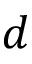<formula> <loc_0><loc_0><loc_500><loc_500>d</formula> 